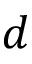<formula> <loc_0><loc_0><loc_500><loc_500>d</formula> 